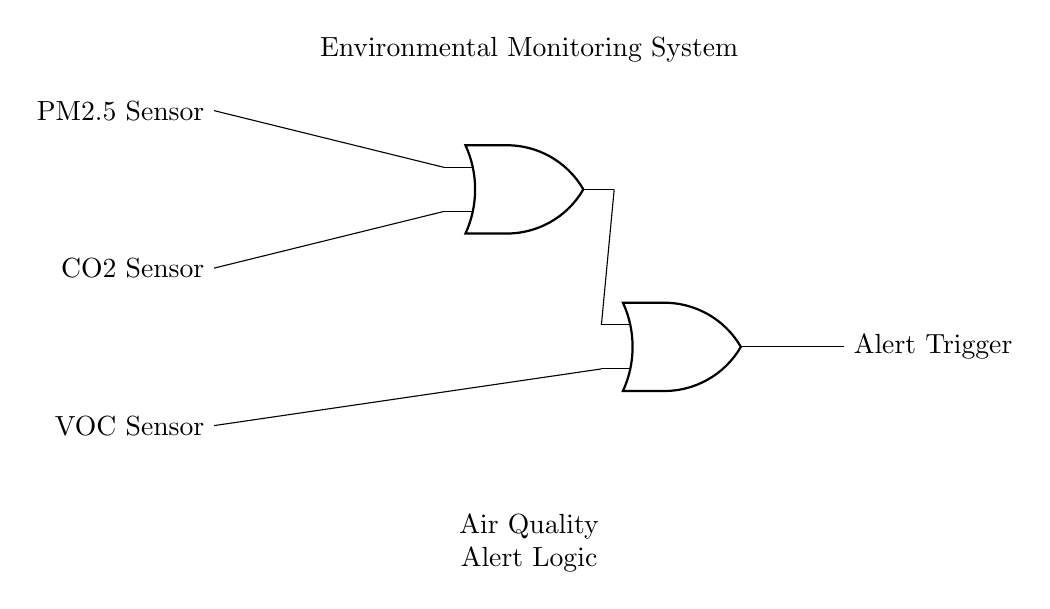What types of sensors are used in this circuit? The circuit diagram shows three types of sensors: a PM2.5 sensor for particulate matter, a CO2 sensor for carbon dioxide, and a VOC sensor for volatile organic compounds.
Answer: PM2.5, CO2, VOC How many OR gates are present in this circuit? The diagram clearly depicts two OR gates connected in a hierarchical structure to process the inputs from the sensors and produce an output.
Answer: 2 What do the OR gates output when triggered? The output of the OR gates triggers an alert for air quality issues when at least one of the inputs is activated, indicating a potential environmental concern.
Answer: Alert Trigger Which sensors connect to the first OR gate? The first OR gate is connected to the PM2.5 and CO2 sensors, as indicated by the lines drawn towards the gate from these two sensors at the top of the diagram.
Answer: PM2.5, CO2 What is the function of the second OR gate in this circuit? The second OR gate takes output from the first OR gate and the VOC sensor, linking both to ultimately determine if an alert should be triggered based on the combined sensor readings.
Answer: Combine alerts What is the overall purpose of this environmental monitoring system? The system is designed to monitor air quality and trigger alerts when pollutant levels reach concerning thresholds, aiding in public health safety.
Answer: Air quality monitoring 